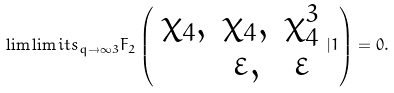Convert formula to latex. <formula><loc_0><loc_0><loc_500><loc_500>\lim \lim i t s _ { q \to \infty } { _ { 3 } } F _ { 2 } \left ( \begin{array} { c c c } \chi _ { 4 } , & \chi _ { 4 } , & \chi _ { 4 } ^ { 3 } \\ & \varepsilon , & \varepsilon \end{array} | 1 \right ) = 0 .</formula> 